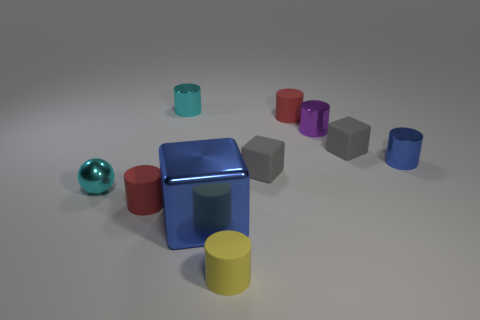How big is the shiny cube?
Your answer should be compact. Large. What is the shape of the tiny thing that is left of the blue cylinder and on the right side of the tiny purple metal cylinder?
Keep it short and to the point. Cube. How many red objects are either large matte cubes or rubber objects?
Keep it short and to the point. 2. There is a shiny cylinder that is left of the big blue shiny object; does it have the same size as the blue shiny cylinder on the right side of the small purple cylinder?
Ensure brevity in your answer.  Yes. How many things are tiny objects or tiny matte things?
Offer a very short reply. 9. Are there any purple things of the same shape as the small yellow matte thing?
Your answer should be compact. Yes. Is the number of small gray objects less than the number of cyan metallic balls?
Your answer should be compact. No. Is the yellow thing the same shape as the purple metallic object?
Ensure brevity in your answer.  Yes. How many things are large blue shiny cylinders or rubber objects that are in front of the blue block?
Your answer should be very brief. 1. How many red matte cylinders are there?
Provide a succinct answer. 2. 